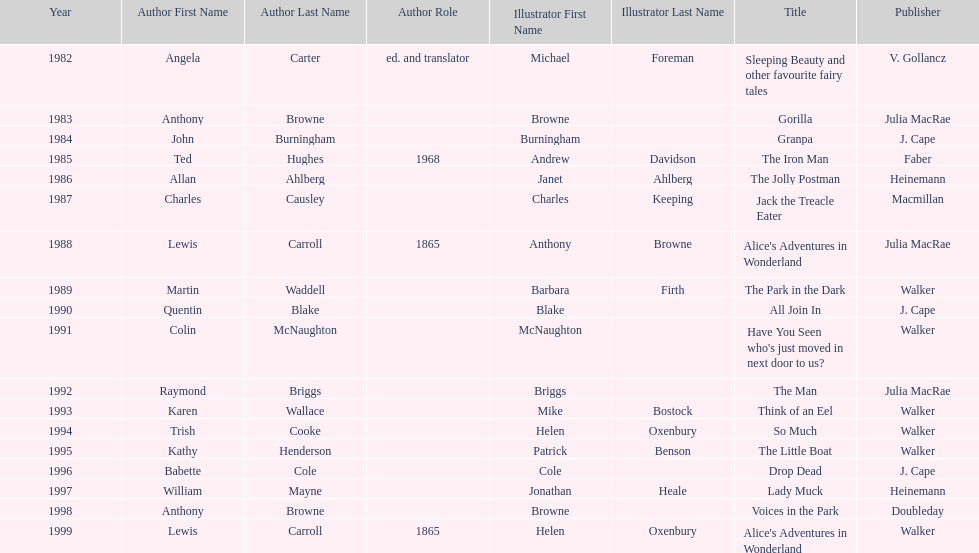Which book won the award a total of 2 times? Alice's Adventures in Wonderland. 